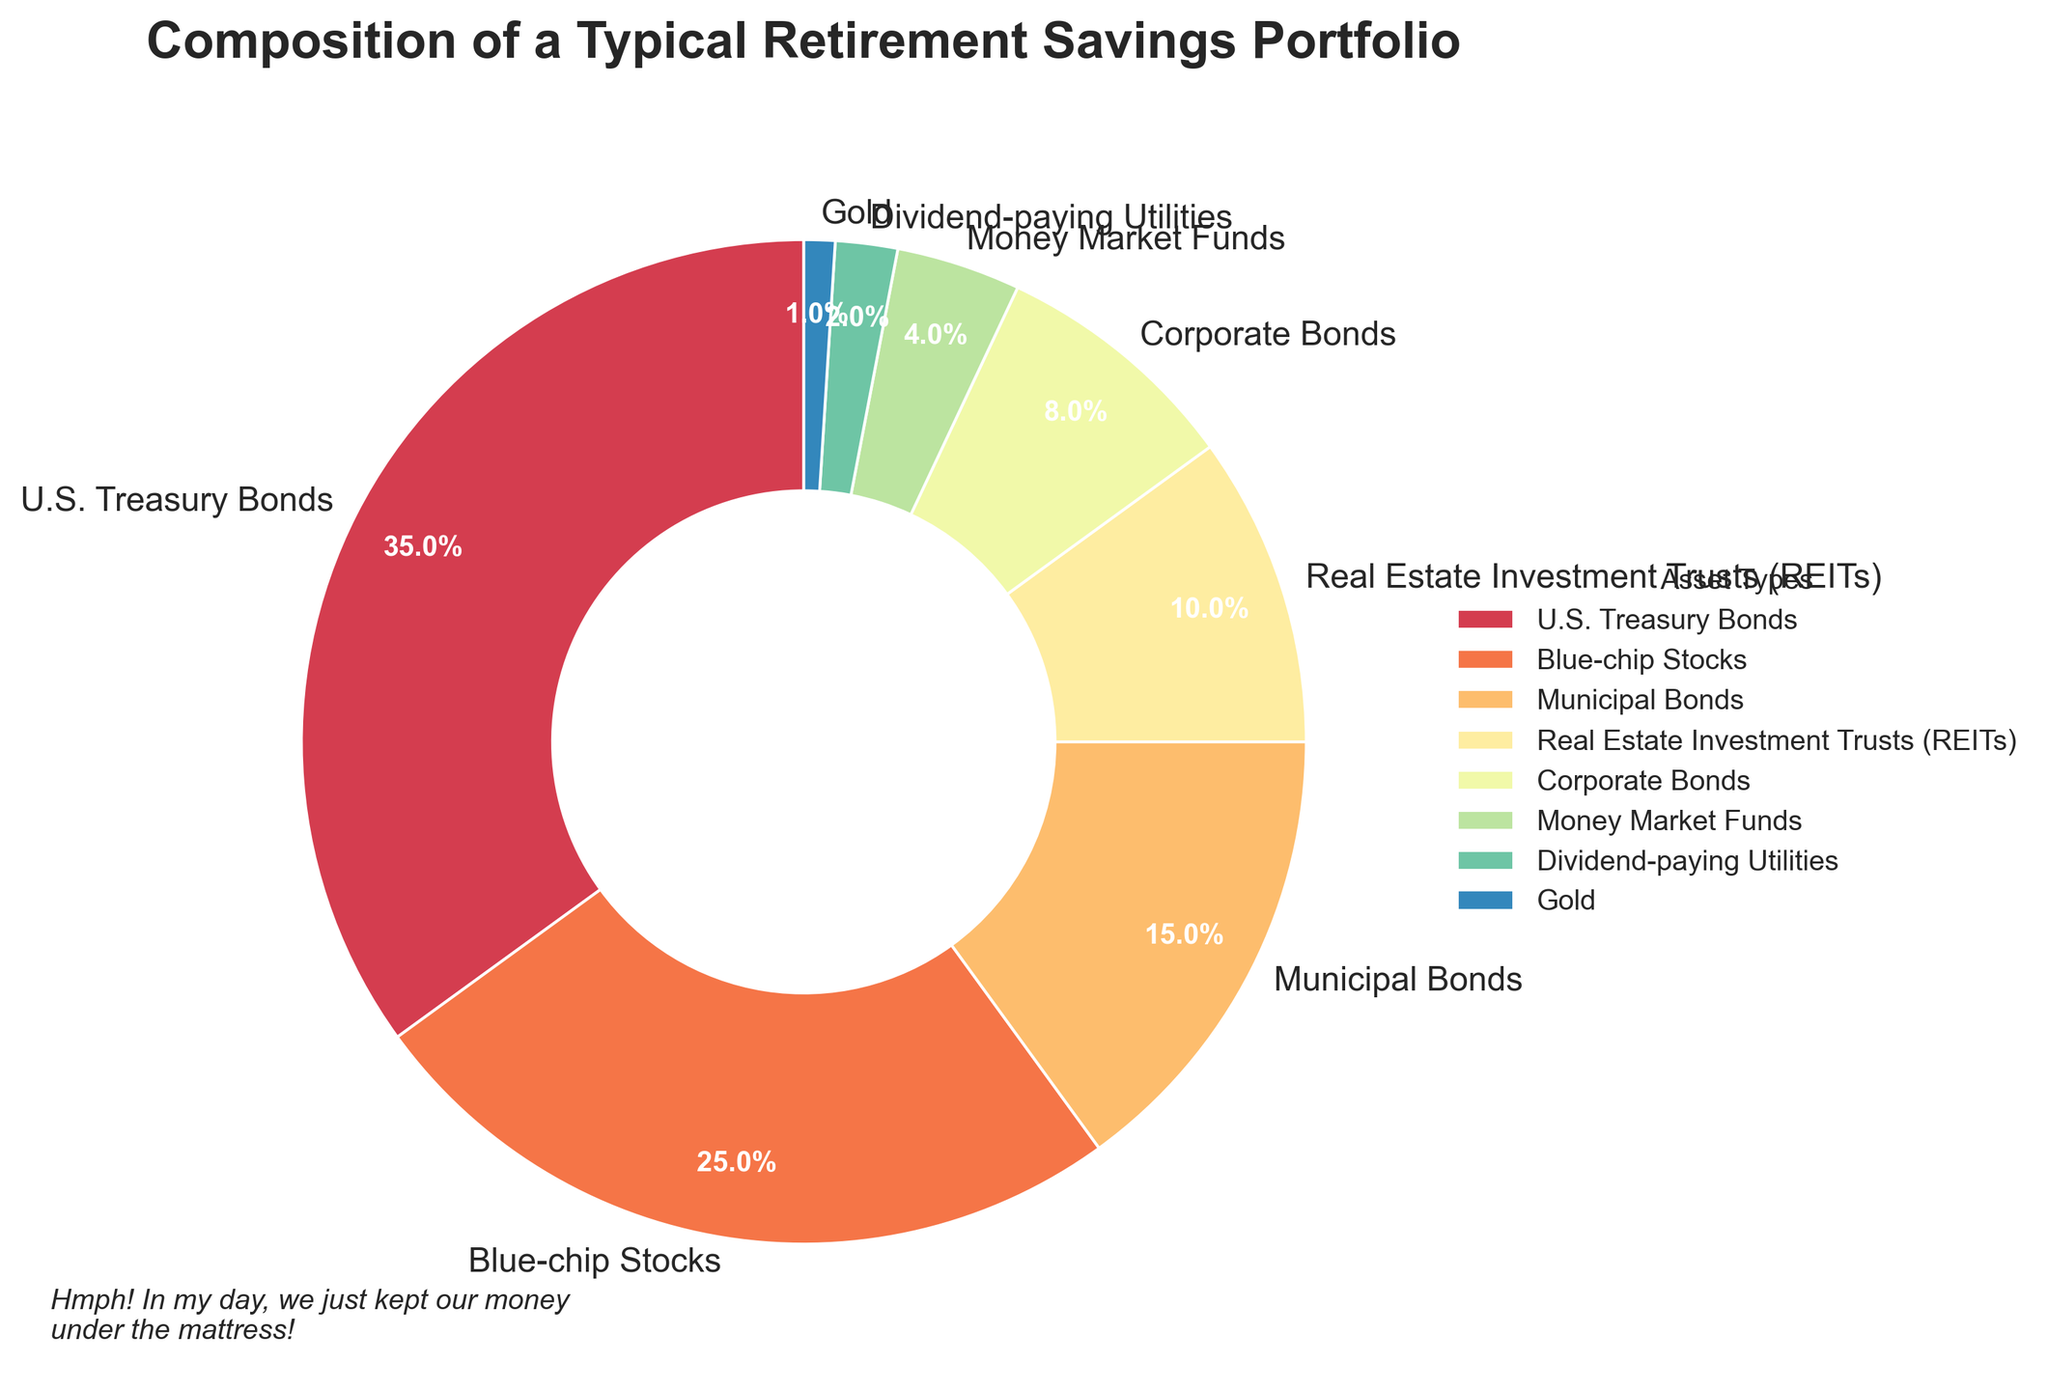what is the most heavily weighted asset in this portfolio? To find the most heavily weighted asset, look for the asset type with the highest percentage in the pie chart. The percentage for U.S. Treasury Bonds is 35%, which is the highest.
Answer: U.S. Treasury Bonds which two asset types make up 40% of the portfolio together? Add the percentages of different asset types to find the two that sum to 40%. Blue-chip Stocks (25%) and Municipal Bonds (15%) together account for 40%.
Answer: Blue-chip Stocks and Municipal Bonds how much more percentage is invested in Blue-chip Stocks compared to Money Market Funds? Look at the percentages for Blue-chip Stocks (25%) and Money Market Funds (4%). The difference is 25% - 4% = 21%.
Answer: 21% is the investment in Corporate Bonds larger or smaller than the investment in Gold? Compare the percentage of Corporate Bonds (8%) with Gold (1%). 8% is larger than 1%.
Answer: Larger what is the combined percentage of investments in Real Estate Investment Trusts (REITs) and Dividend-paying Utilities? Add the percentages for REITs (10%) and Dividend-paying Utilities (2%). The combined percentage is 10% + 2% = 12%.
Answer: 12% which asset type appears next to Blue-chip Stocks in the pie chart? In the pie chart, REITs are visually next to Blue-chip Stocks. This can be determined by the arrangement of the colored sections.
Answer: Real Estate Investment Trusts (REITs) how many asset types have a percentage greater than 10%? Identify the asset types with percentages greater than 10%. U.S. Treasury Bonds (35%) and Blue-chip Stocks (25%) meet this criterion.
Answer: 2 asset types is the total investment in Bonds (U.S. Treasury Bonds, Municipal Bonds, Corporate Bonds) more than 50%? Sum the percentages of U.S. Treasury Bonds (35%), Municipal Bonds (15%), and Corporate Bonds (8%). The total is 35% + 15% + 8% = 58%, which is greater than 50%.
Answer: Yes which asset type is the smallest portion of this portfolio? Look for the asset type with the smallest percentage in the pie chart. Gold has the smallest percentage, which is 1%.
Answer: Gold how does the percentage of U.S. Treasury Bonds compare to the combined percentage of REITs and Corporate Bonds? The percentage of U.S. Treasury Bonds is 35%. The combined percentage of REITs (10%) and Corporate Bonds (8%) is 10% + 8% = 18%. 35% is greater than 18%.
Answer: Larger 